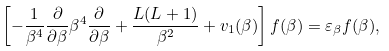Convert formula to latex. <formula><loc_0><loc_0><loc_500><loc_500>\left [ - \frac { 1 } { \beta ^ { 4 } } \frac { \partial } { \partial \beta } \beta ^ { 4 } \frac { \partial } { \partial \beta } + \frac { L ( L + 1 ) } { \beta ^ { 2 } } + v _ { 1 } ( \beta ) \right ] f ( \beta ) = \varepsilon _ { \beta } f ( \beta ) ,</formula> 